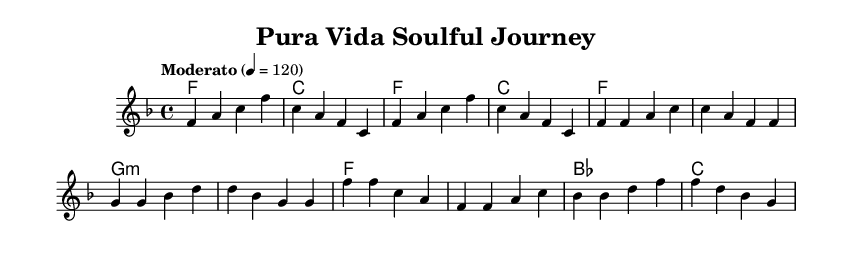What is the key signature of this music? The key signature is indicated by the number of sharps or flats. In this case, the music is written in F major, which has one flat (B flat).
Answer: F major What is the time signature of this piece? The time signature is found at the beginning of the music. Here, it is indicated as 4/4, meaning there are four beats in each measure.
Answer: 4/4 What is the tempo marking for this music? The tempo marking is found in the header section and indicates how fast the piece should be played. In this music, it is marked as "Moderato", with a metronome marking of 120 beats per minute.
Answer: Moderato How many measures are in the verse section? To count the measures in the verse, I look at the melody line where the verse starts and ends. Here, the melody for the verse has four measures.
Answer: 4 What is the chord for the chorus section? The chords for the chorus section are indicated below the melody. The first chord of the chorus is F major, followed by F major, B flat major, and C major.
Answer: F In which section do we find the G minor chord? By examining the harmony section, I can see that the G minor chord appears during the verse section. This can be identified by its position in the line of chords.
Answer: Verse What is the melodic motif in the intro? The melodic motif in the introduction can be identified by the repeating notes and rhythms. It consists of a series of ascending and descending notes starting with F, creating a recognizable pattern.
Answer: F A C F 